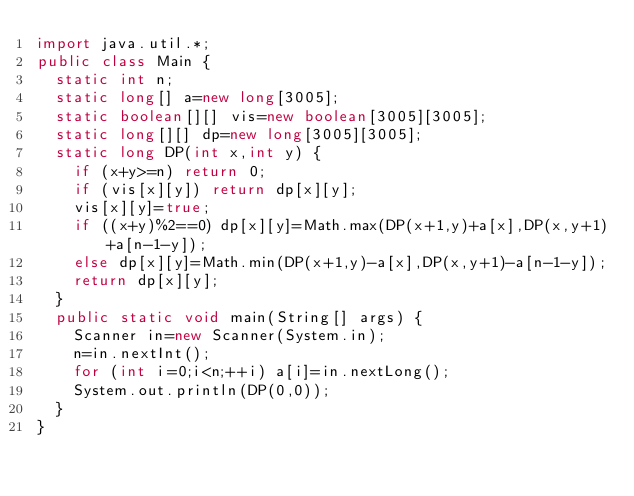Convert code to text. <code><loc_0><loc_0><loc_500><loc_500><_Java_>import java.util.*;
public class Main {
	static int n;
	static long[] a=new long[3005];
	static boolean[][] vis=new boolean[3005][3005];
	static long[][] dp=new long[3005][3005];
	static long DP(int x,int y) {
		if (x+y>=n) return 0;
		if (vis[x][y]) return dp[x][y];
		vis[x][y]=true;
		if ((x+y)%2==0) dp[x][y]=Math.max(DP(x+1,y)+a[x],DP(x,y+1)+a[n-1-y]);
		else dp[x][y]=Math.min(DP(x+1,y)-a[x],DP(x,y+1)-a[n-1-y]);
		return dp[x][y];
	}
	public static void main(String[] args) {
		Scanner in=new Scanner(System.in);
		n=in.nextInt();
		for (int i=0;i<n;++i) a[i]=in.nextLong();
		System.out.println(DP(0,0));
	}
}</code> 